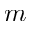Convert formula to latex. <formula><loc_0><loc_0><loc_500><loc_500>m</formula> 